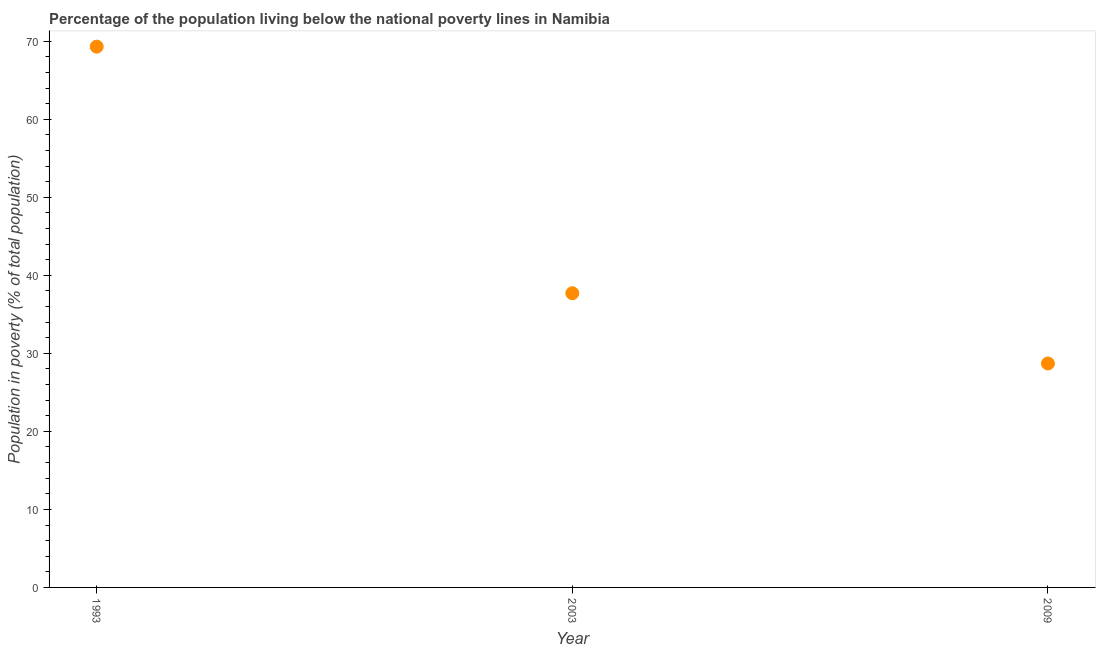What is the percentage of population living below poverty line in 1993?
Provide a succinct answer. 69.3. Across all years, what is the maximum percentage of population living below poverty line?
Ensure brevity in your answer.  69.3. Across all years, what is the minimum percentage of population living below poverty line?
Your response must be concise. 28.7. In which year was the percentage of population living below poverty line minimum?
Offer a terse response. 2009. What is the sum of the percentage of population living below poverty line?
Offer a terse response. 135.7. What is the difference between the percentage of population living below poverty line in 2003 and 2009?
Keep it short and to the point. 9. What is the average percentage of population living below poverty line per year?
Provide a short and direct response. 45.23. What is the median percentage of population living below poverty line?
Ensure brevity in your answer.  37.7. In how many years, is the percentage of population living below poverty line greater than 30 %?
Your answer should be compact. 2. Do a majority of the years between 2003 and 2009 (inclusive) have percentage of population living below poverty line greater than 28 %?
Provide a short and direct response. Yes. What is the ratio of the percentage of population living below poverty line in 1993 to that in 2009?
Offer a terse response. 2.41. Is the percentage of population living below poverty line in 1993 less than that in 2003?
Your answer should be compact. No. What is the difference between the highest and the second highest percentage of population living below poverty line?
Provide a succinct answer. 31.6. What is the difference between the highest and the lowest percentage of population living below poverty line?
Provide a succinct answer. 40.6. In how many years, is the percentage of population living below poverty line greater than the average percentage of population living below poverty line taken over all years?
Provide a short and direct response. 1. Does the percentage of population living below poverty line monotonically increase over the years?
Your response must be concise. No. How many dotlines are there?
Provide a short and direct response. 1. What is the difference between two consecutive major ticks on the Y-axis?
Ensure brevity in your answer.  10. Does the graph contain any zero values?
Ensure brevity in your answer.  No. Does the graph contain grids?
Your answer should be very brief. No. What is the title of the graph?
Make the answer very short. Percentage of the population living below the national poverty lines in Namibia. What is the label or title of the X-axis?
Your answer should be very brief. Year. What is the label or title of the Y-axis?
Offer a terse response. Population in poverty (% of total population). What is the Population in poverty (% of total population) in 1993?
Ensure brevity in your answer.  69.3. What is the Population in poverty (% of total population) in 2003?
Offer a very short reply. 37.7. What is the Population in poverty (% of total population) in 2009?
Ensure brevity in your answer.  28.7. What is the difference between the Population in poverty (% of total population) in 1993 and 2003?
Keep it short and to the point. 31.6. What is the difference between the Population in poverty (% of total population) in 1993 and 2009?
Provide a succinct answer. 40.6. What is the difference between the Population in poverty (% of total population) in 2003 and 2009?
Your answer should be compact. 9. What is the ratio of the Population in poverty (% of total population) in 1993 to that in 2003?
Ensure brevity in your answer.  1.84. What is the ratio of the Population in poverty (% of total population) in 1993 to that in 2009?
Your response must be concise. 2.42. What is the ratio of the Population in poverty (% of total population) in 2003 to that in 2009?
Provide a succinct answer. 1.31. 